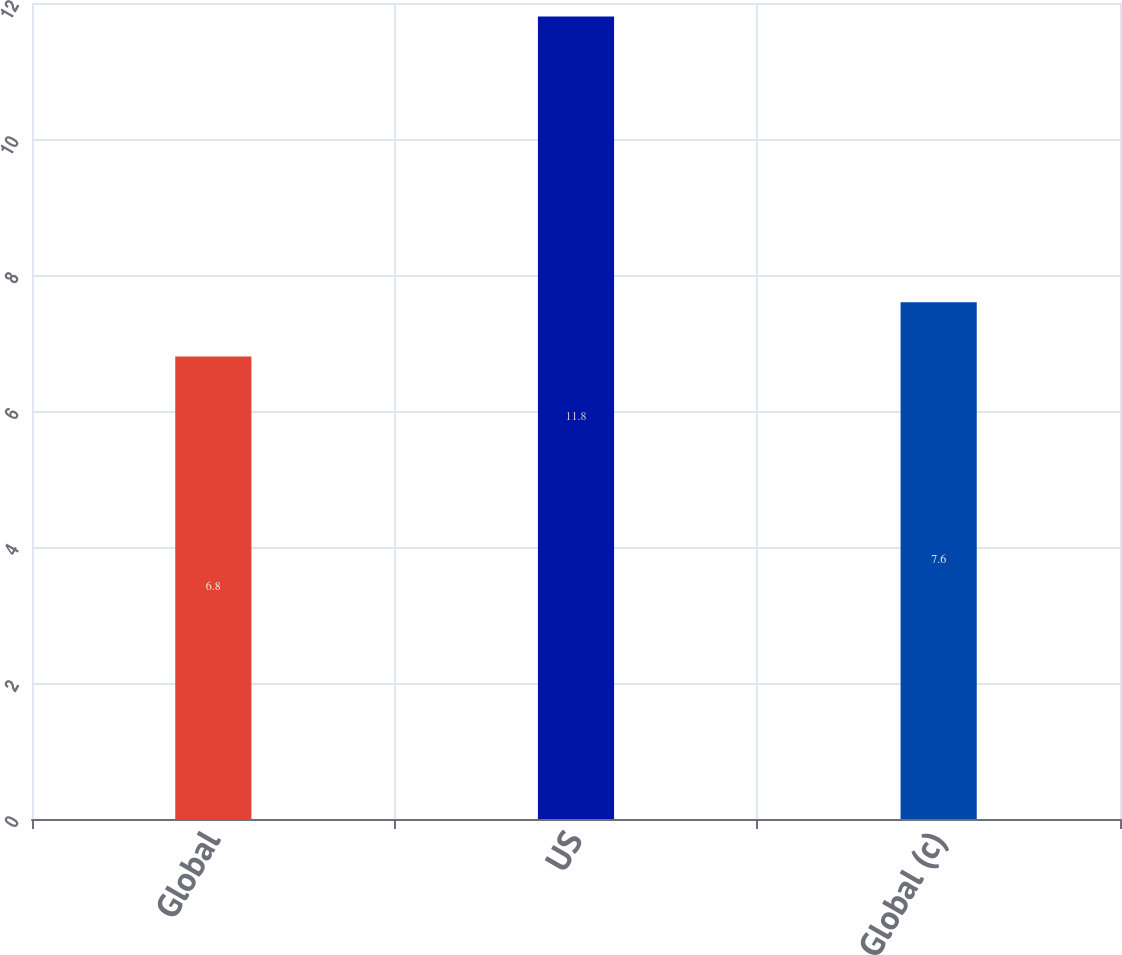Convert chart to OTSL. <chart><loc_0><loc_0><loc_500><loc_500><bar_chart><fcel>Global<fcel>US<fcel>Global (c)<nl><fcel>6.8<fcel>11.8<fcel>7.6<nl></chart> 